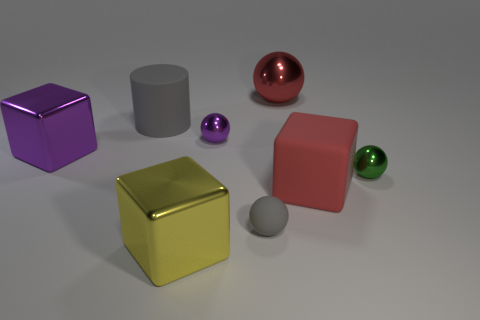Is there anything else that is the same shape as the large gray matte object?
Make the answer very short. No. How many other objects are the same color as the big rubber block?
Your response must be concise. 1. What is the shape of the red matte thing that is the same size as the yellow block?
Provide a succinct answer. Cube. What number of tiny objects are metal cylinders or gray matte balls?
Provide a short and direct response. 1. Are there any metallic objects behind the small shiny sphere to the left of the metallic ball that is on the right side of the large red sphere?
Provide a succinct answer. Yes. Is there a yellow matte cylinder that has the same size as the green ball?
Your response must be concise. No. There is a purple thing that is the same size as the yellow block; what is its material?
Give a very brief answer. Metal. Do the red cube and the gray object that is in front of the green metallic object have the same size?
Keep it short and to the point. No. How many rubber objects are either big spheres or gray objects?
Make the answer very short. 2. How many other shiny things have the same shape as the big yellow thing?
Offer a terse response. 1. 